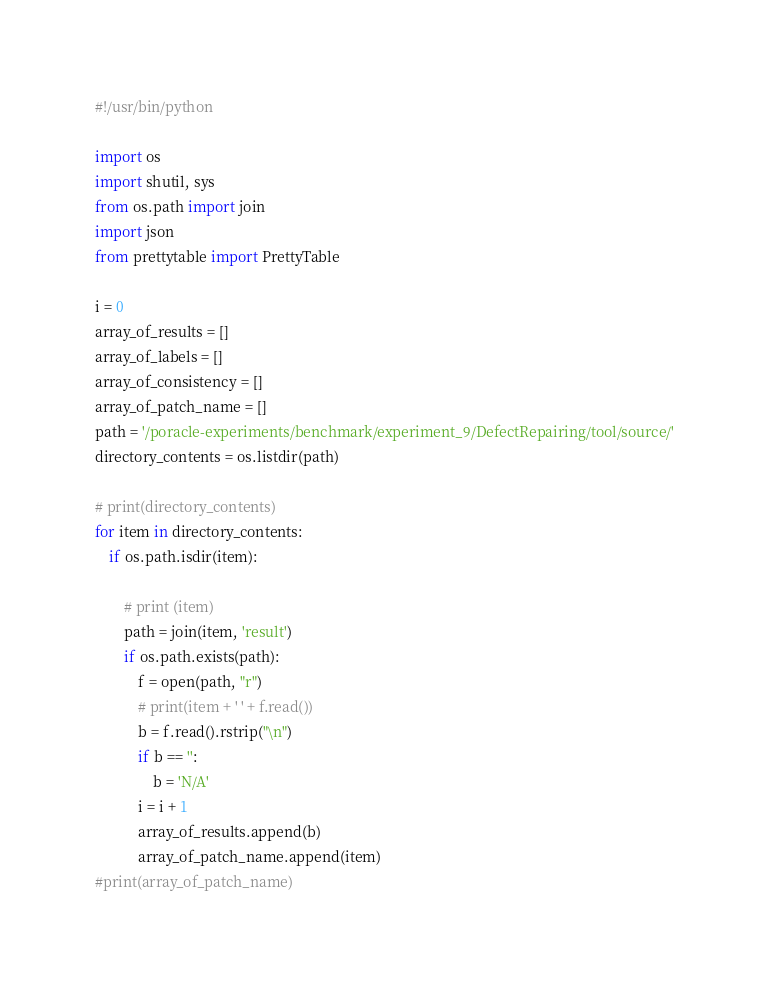Convert code to text. <code><loc_0><loc_0><loc_500><loc_500><_Python_>#!/usr/bin/python

import os
import shutil, sys
from os.path import join
import json
from prettytable import PrettyTable

i = 0
array_of_results = []
array_of_labels = []
array_of_consistency = []
array_of_patch_name = []
path = '/poracle-experiments/benchmark/experiment_9/DefectRepairing/tool/source/'
directory_contents = os.listdir(path)

# print(directory_contents)
for item in directory_contents:
    if os.path.isdir(item):

        # print (item)
        path = join(item, 'result')
        if os.path.exists(path):
            f = open(path, "r")
            # print(item + ' ' + f.read())
            b = f.read().rstrip("\n")
            if b == '':
                b = 'N/A'
            i = i + 1
            array_of_results.append(b)
            array_of_patch_name.append(item)
#print(array_of_patch_name)</code> 